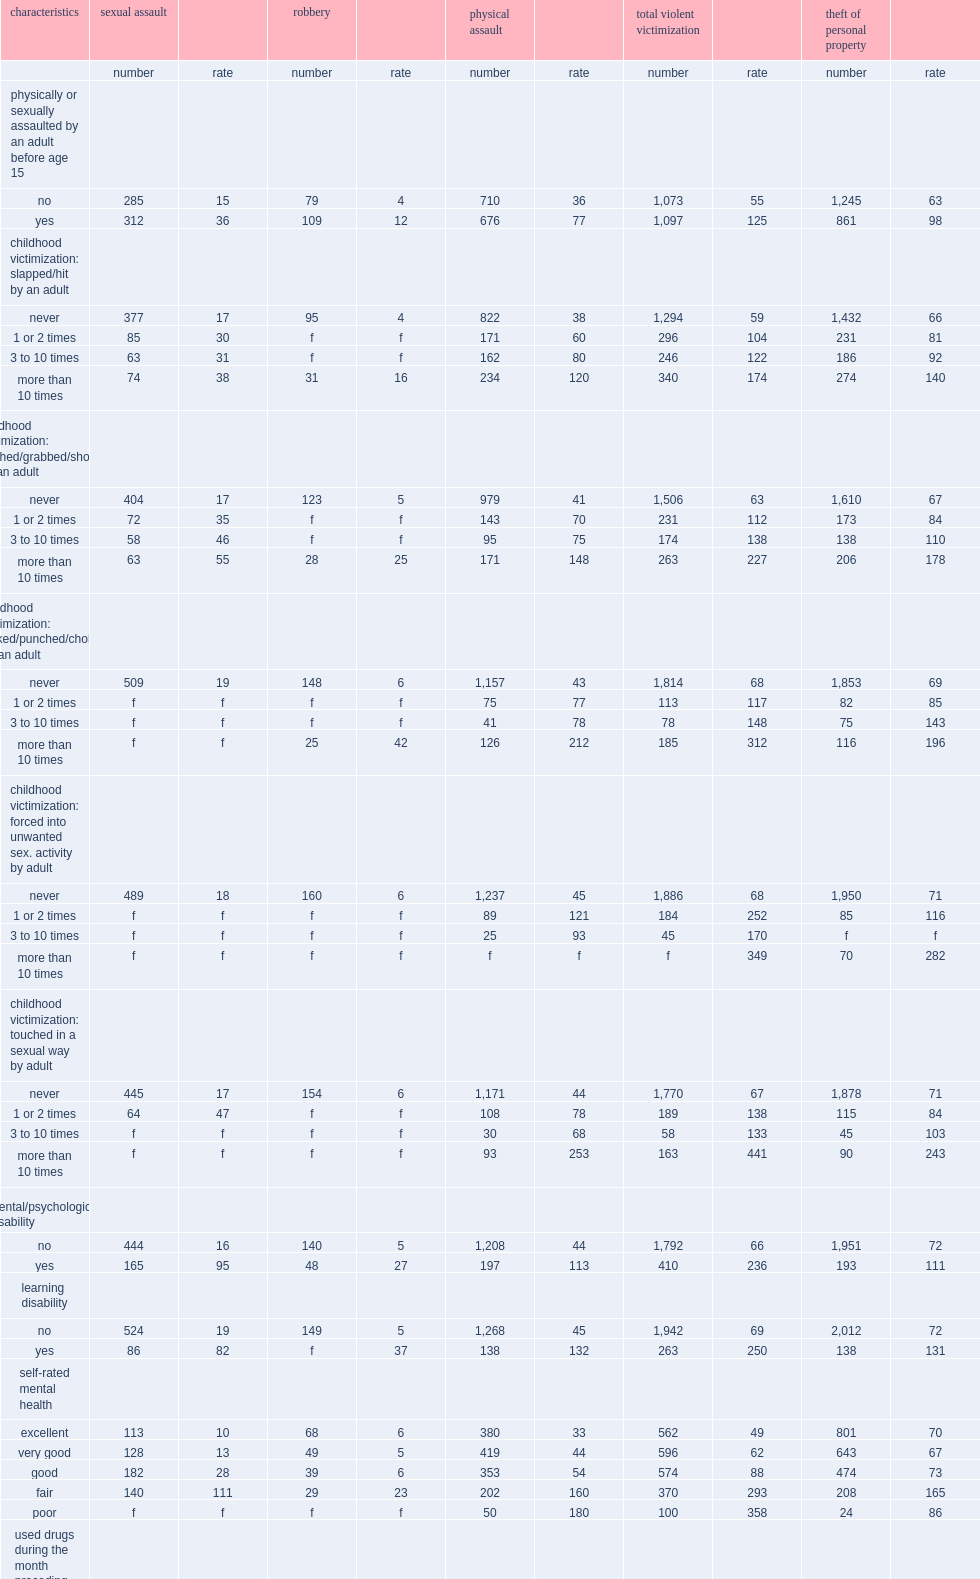How many times was the victimization rate of people who stated that they used drugs during the month preceding the survey than non-users? 4.129032. What was the rate of violent victimization among people who reported using cannabis daily? 436.0. What was the rate of violent victimization among people who used drugs other than cannabis? 610.0. How many times was the victimization rate of people drinking episode-that is, at least five alcoholic drinks on a single occasion- during the month preceding the survey more than those who did not do so? 2.189655. Did people who drink alcohol frequently but not to the extent that their consumption would be considered binge drinking report higher than average rates of violent victimization? None. How many times was the victimization rate of people who reported more than 20 evening activities per month more than that of people who never went out in the evening? 1.831169. How many times was the violent victimization rate of people who experienced child maltreatment more than that of people who did not experience such abuse? 2.272727. How many times was the victimization rate of people who had been homeless at some point in their lifetime more than people who had never been homeless? 5.966667. 